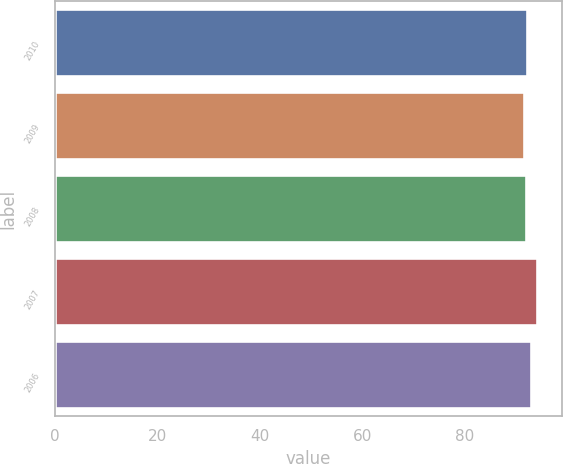<chart> <loc_0><loc_0><loc_500><loc_500><bar_chart><fcel>2010<fcel>2009<fcel>2008<fcel>2007<fcel>2006<nl><fcel>92.16<fcel>91.5<fcel>91.9<fcel>94.1<fcel>92.9<nl></chart> 